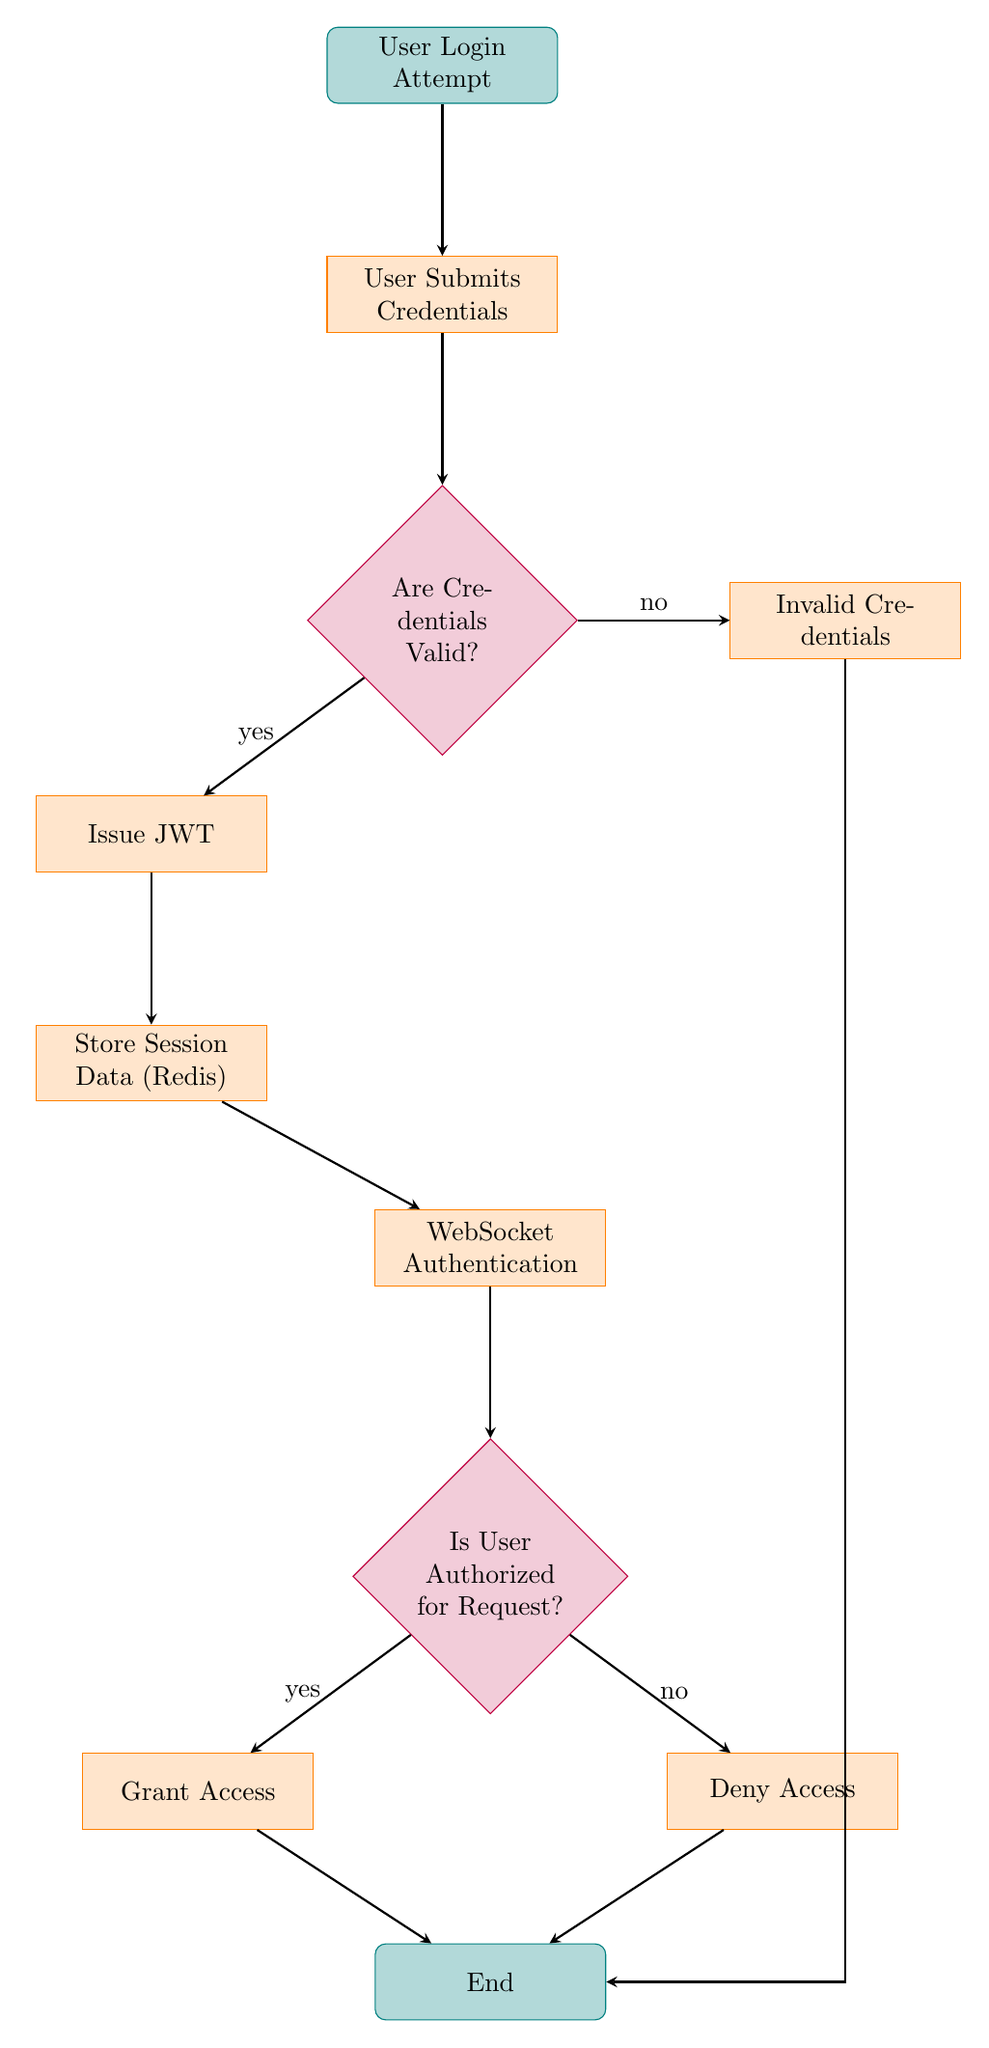What is the first step in the flow chart? The first step in the flow chart is "User Login Attempt," which is represented at the top as the starting node. The flow starts with this action.
Answer: User Login Attempt How many decision nodes are present in the flow chart? The flow chart contains two decision nodes: "Are Credentials Valid?" and "Is User Authorized for Request?" These nodes represent points where the flow can split based on yes/no outcomes.
Answer: 2 What happens if the credentials are invalid? If the credentials are invalid, the flow proceeds to the "Invalid Credentials" process node, and subsequently leads to the "End" node. This shows that invalid credentials halt the process.
Answer: Invalid Credentials What is issued after validating credentials? After validating credentials, the flow moves to the "Issue JWT" process, indicating that a JSON Web Token is created for the user.
Answer: Issue JWT What is the process that follows after storing session data? After the "Store Session Data (Redis)" process, the next step in the flow is "WebSocket Authentication," which involves authenticating the user for WebSocket connections.
Answer: WebSocket Authentication If a user is authorized, what process follows? If a user is authorized for a request, the flow proceeds to the "Grant Access" process, allowing the user to access the requested resource.
Answer: Grant Access Which process occurs when the user is denied access? When the user is denied access after authorization, the flow leads to the "Deny Access" process, indicating that the request is not permitted.
Answer: Deny Access What is the final outcome of the flow chart? The final outcome of the flow chart is represented by the "End" node, which signifies the conclusion of the authentication and authorization process.
Answer: End 